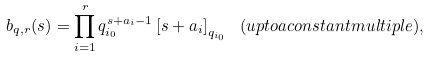<formula> <loc_0><loc_0><loc_500><loc_500>b _ { q , r } ( s ) = \prod _ { i = 1 } ^ { r } q _ { i _ { 0 } } ^ { s + a _ { i } - 1 } \left [ s + a _ { i } \right ] _ { q _ { i _ { 0 } } } \ ( { u p t o a c o n s t a n t m u l t i p l e } ) ,</formula> 